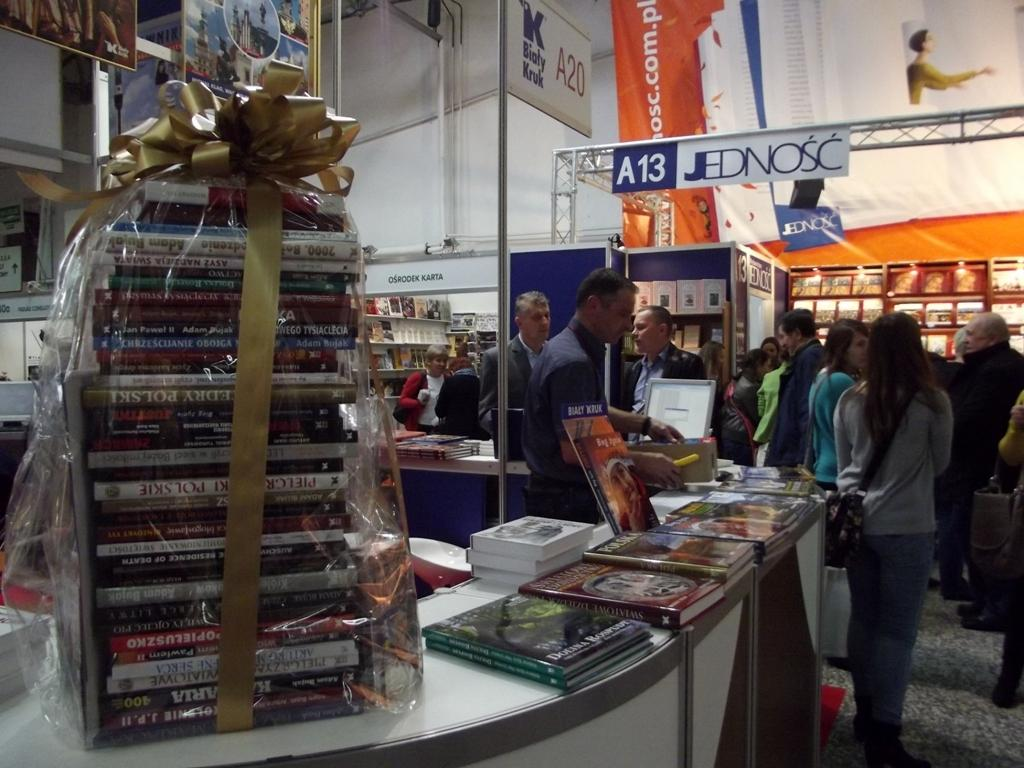<image>
Give a short and clear explanation of the subsequent image. a sales kiosk in a large building under the A13 arch 